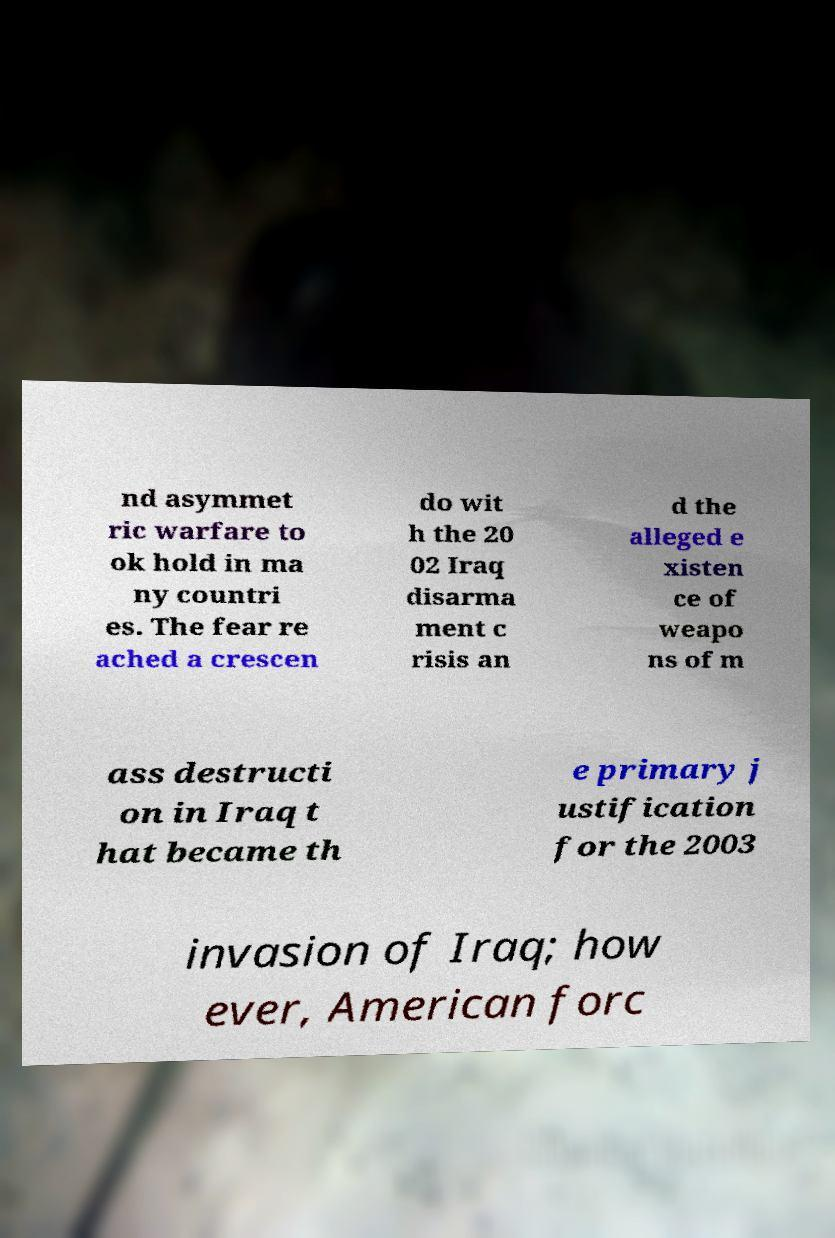Could you assist in decoding the text presented in this image and type it out clearly? nd asymmet ric warfare to ok hold in ma ny countri es. The fear re ached a crescen do wit h the 20 02 Iraq disarma ment c risis an d the alleged e xisten ce of weapo ns of m ass destructi on in Iraq t hat became th e primary j ustification for the 2003 invasion of Iraq; how ever, American forc 